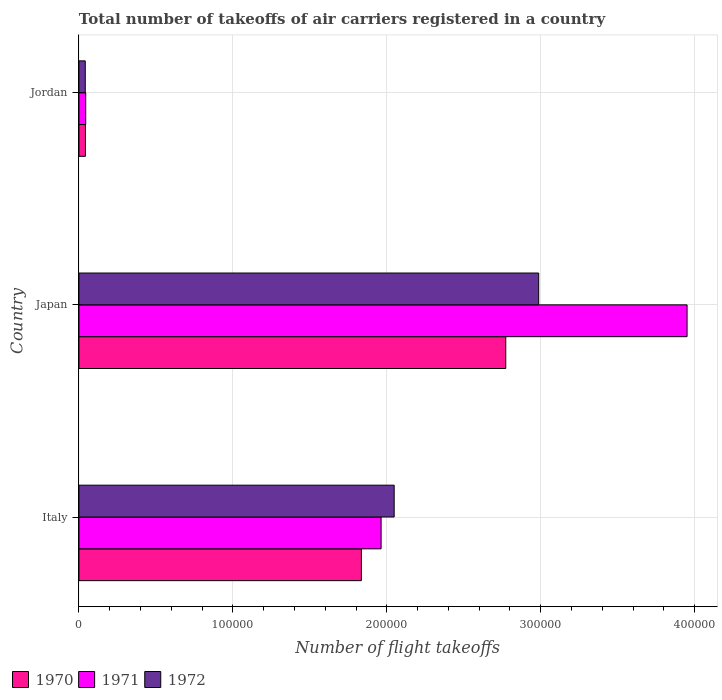How many different coloured bars are there?
Provide a succinct answer. 3. What is the label of the 2nd group of bars from the top?
Give a very brief answer. Japan. What is the total number of flight takeoffs in 1971 in Japan?
Offer a very short reply. 3.95e+05. Across all countries, what is the maximum total number of flight takeoffs in 1972?
Give a very brief answer. 2.99e+05. Across all countries, what is the minimum total number of flight takeoffs in 1971?
Provide a short and direct response. 4400. In which country was the total number of flight takeoffs in 1970 minimum?
Offer a very short reply. Jordan. What is the total total number of flight takeoffs in 1971 in the graph?
Your response must be concise. 5.96e+05. What is the difference between the total number of flight takeoffs in 1970 in Italy and that in Jordan?
Your answer should be compact. 1.79e+05. What is the difference between the total number of flight takeoffs in 1972 in Italy and the total number of flight takeoffs in 1970 in Jordan?
Give a very brief answer. 2.01e+05. What is the average total number of flight takeoffs in 1971 per country?
Make the answer very short. 1.99e+05. What is the difference between the total number of flight takeoffs in 1971 and total number of flight takeoffs in 1972 in Italy?
Make the answer very short. -8500. What is the ratio of the total number of flight takeoffs in 1970 in Italy to that in Jordan?
Ensure brevity in your answer.  43.69. What is the difference between the highest and the second highest total number of flight takeoffs in 1971?
Your response must be concise. 1.99e+05. What is the difference between the highest and the lowest total number of flight takeoffs in 1971?
Keep it short and to the point. 3.91e+05. In how many countries, is the total number of flight takeoffs in 1970 greater than the average total number of flight takeoffs in 1970 taken over all countries?
Offer a terse response. 2. Is the sum of the total number of flight takeoffs in 1970 in Italy and Japan greater than the maximum total number of flight takeoffs in 1971 across all countries?
Offer a very short reply. Yes. What does the 3rd bar from the top in Italy represents?
Provide a succinct answer. 1970. What does the 2nd bar from the bottom in Jordan represents?
Your answer should be very brief. 1971. Is it the case that in every country, the sum of the total number of flight takeoffs in 1971 and total number of flight takeoffs in 1970 is greater than the total number of flight takeoffs in 1972?
Ensure brevity in your answer.  Yes. Are all the bars in the graph horizontal?
Provide a short and direct response. Yes. How many countries are there in the graph?
Provide a succinct answer. 3. What is the difference between two consecutive major ticks on the X-axis?
Your response must be concise. 1.00e+05. Are the values on the major ticks of X-axis written in scientific E-notation?
Provide a short and direct response. No. How many legend labels are there?
Provide a short and direct response. 3. What is the title of the graph?
Provide a short and direct response. Total number of takeoffs of air carriers registered in a country. What is the label or title of the X-axis?
Your answer should be compact. Number of flight takeoffs. What is the label or title of the Y-axis?
Provide a short and direct response. Country. What is the Number of flight takeoffs of 1970 in Italy?
Your answer should be compact. 1.84e+05. What is the Number of flight takeoffs of 1971 in Italy?
Your answer should be compact. 1.96e+05. What is the Number of flight takeoffs of 1972 in Italy?
Provide a succinct answer. 2.05e+05. What is the Number of flight takeoffs of 1970 in Japan?
Your answer should be compact. 2.77e+05. What is the Number of flight takeoffs of 1971 in Japan?
Provide a succinct answer. 3.95e+05. What is the Number of flight takeoffs of 1972 in Japan?
Make the answer very short. 2.99e+05. What is the Number of flight takeoffs of 1970 in Jordan?
Your answer should be compact. 4200. What is the Number of flight takeoffs of 1971 in Jordan?
Make the answer very short. 4400. What is the Number of flight takeoffs in 1972 in Jordan?
Offer a very short reply. 4100. Across all countries, what is the maximum Number of flight takeoffs of 1970?
Give a very brief answer. 2.77e+05. Across all countries, what is the maximum Number of flight takeoffs in 1971?
Ensure brevity in your answer.  3.95e+05. Across all countries, what is the maximum Number of flight takeoffs of 1972?
Your answer should be very brief. 2.99e+05. Across all countries, what is the minimum Number of flight takeoffs of 1970?
Your response must be concise. 4200. Across all countries, what is the minimum Number of flight takeoffs of 1971?
Your answer should be very brief. 4400. Across all countries, what is the minimum Number of flight takeoffs of 1972?
Provide a short and direct response. 4100. What is the total Number of flight takeoffs in 1970 in the graph?
Your response must be concise. 4.65e+05. What is the total Number of flight takeoffs of 1971 in the graph?
Offer a very short reply. 5.96e+05. What is the total Number of flight takeoffs of 1972 in the graph?
Make the answer very short. 5.08e+05. What is the difference between the Number of flight takeoffs of 1970 in Italy and that in Japan?
Give a very brief answer. -9.38e+04. What is the difference between the Number of flight takeoffs of 1971 in Italy and that in Japan?
Your response must be concise. -1.99e+05. What is the difference between the Number of flight takeoffs in 1972 in Italy and that in Japan?
Keep it short and to the point. -9.39e+04. What is the difference between the Number of flight takeoffs of 1970 in Italy and that in Jordan?
Offer a terse response. 1.79e+05. What is the difference between the Number of flight takeoffs in 1971 in Italy and that in Jordan?
Ensure brevity in your answer.  1.92e+05. What is the difference between the Number of flight takeoffs of 1972 in Italy and that in Jordan?
Ensure brevity in your answer.  2.01e+05. What is the difference between the Number of flight takeoffs in 1970 in Japan and that in Jordan?
Provide a short and direct response. 2.73e+05. What is the difference between the Number of flight takeoffs in 1971 in Japan and that in Jordan?
Make the answer very short. 3.91e+05. What is the difference between the Number of flight takeoffs in 1972 in Japan and that in Jordan?
Ensure brevity in your answer.  2.95e+05. What is the difference between the Number of flight takeoffs in 1970 in Italy and the Number of flight takeoffs in 1971 in Japan?
Offer a very short reply. -2.12e+05. What is the difference between the Number of flight takeoffs of 1970 in Italy and the Number of flight takeoffs of 1972 in Japan?
Give a very brief answer. -1.15e+05. What is the difference between the Number of flight takeoffs of 1971 in Italy and the Number of flight takeoffs of 1972 in Japan?
Ensure brevity in your answer.  -1.02e+05. What is the difference between the Number of flight takeoffs of 1970 in Italy and the Number of flight takeoffs of 1971 in Jordan?
Offer a very short reply. 1.79e+05. What is the difference between the Number of flight takeoffs in 1970 in Italy and the Number of flight takeoffs in 1972 in Jordan?
Offer a terse response. 1.79e+05. What is the difference between the Number of flight takeoffs of 1971 in Italy and the Number of flight takeoffs of 1972 in Jordan?
Provide a short and direct response. 1.92e+05. What is the difference between the Number of flight takeoffs of 1970 in Japan and the Number of flight takeoffs of 1971 in Jordan?
Keep it short and to the point. 2.73e+05. What is the difference between the Number of flight takeoffs of 1970 in Japan and the Number of flight takeoffs of 1972 in Jordan?
Make the answer very short. 2.73e+05. What is the difference between the Number of flight takeoffs of 1971 in Japan and the Number of flight takeoffs of 1972 in Jordan?
Offer a terse response. 3.91e+05. What is the average Number of flight takeoffs of 1970 per country?
Offer a very short reply. 1.55e+05. What is the average Number of flight takeoffs in 1971 per country?
Give a very brief answer. 1.99e+05. What is the average Number of flight takeoffs of 1972 per country?
Provide a short and direct response. 1.69e+05. What is the difference between the Number of flight takeoffs of 1970 and Number of flight takeoffs of 1971 in Italy?
Your response must be concise. -1.28e+04. What is the difference between the Number of flight takeoffs in 1970 and Number of flight takeoffs in 1972 in Italy?
Keep it short and to the point. -2.13e+04. What is the difference between the Number of flight takeoffs of 1971 and Number of flight takeoffs of 1972 in Italy?
Your response must be concise. -8500. What is the difference between the Number of flight takeoffs of 1970 and Number of flight takeoffs of 1971 in Japan?
Provide a short and direct response. -1.18e+05. What is the difference between the Number of flight takeoffs of 1970 and Number of flight takeoffs of 1972 in Japan?
Give a very brief answer. -2.14e+04. What is the difference between the Number of flight takeoffs in 1971 and Number of flight takeoffs in 1972 in Japan?
Provide a short and direct response. 9.64e+04. What is the difference between the Number of flight takeoffs of 1970 and Number of flight takeoffs of 1971 in Jordan?
Your response must be concise. -200. What is the difference between the Number of flight takeoffs of 1970 and Number of flight takeoffs of 1972 in Jordan?
Offer a terse response. 100. What is the difference between the Number of flight takeoffs in 1971 and Number of flight takeoffs in 1972 in Jordan?
Your response must be concise. 300. What is the ratio of the Number of flight takeoffs of 1970 in Italy to that in Japan?
Provide a short and direct response. 0.66. What is the ratio of the Number of flight takeoffs of 1971 in Italy to that in Japan?
Keep it short and to the point. 0.5. What is the ratio of the Number of flight takeoffs of 1972 in Italy to that in Japan?
Keep it short and to the point. 0.69. What is the ratio of the Number of flight takeoffs in 1970 in Italy to that in Jordan?
Give a very brief answer. 43.69. What is the ratio of the Number of flight takeoffs of 1971 in Italy to that in Jordan?
Make the answer very short. 44.61. What is the ratio of the Number of flight takeoffs in 1972 in Italy to that in Jordan?
Your response must be concise. 49.95. What is the ratio of the Number of flight takeoffs of 1970 in Japan to that in Jordan?
Ensure brevity in your answer.  66.02. What is the ratio of the Number of flight takeoffs in 1971 in Japan to that in Jordan?
Your response must be concise. 89.8. What is the ratio of the Number of flight takeoffs in 1972 in Japan to that in Jordan?
Make the answer very short. 72.85. What is the difference between the highest and the second highest Number of flight takeoffs of 1970?
Make the answer very short. 9.38e+04. What is the difference between the highest and the second highest Number of flight takeoffs of 1971?
Offer a very short reply. 1.99e+05. What is the difference between the highest and the second highest Number of flight takeoffs in 1972?
Your response must be concise. 9.39e+04. What is the difference between the highest and the lowest Number of flight takeoffs in 1970?
Offer a very short reply. 2.73e+05. What is the difference between the highest and the lowest Number of flight takeoffs in 1971?
Make the answer very short. 3.91e+05. What is the difference between the highest and the lowest Number of flight takeoffs in 1972?
Your response must be concise. 2.95e+05. 